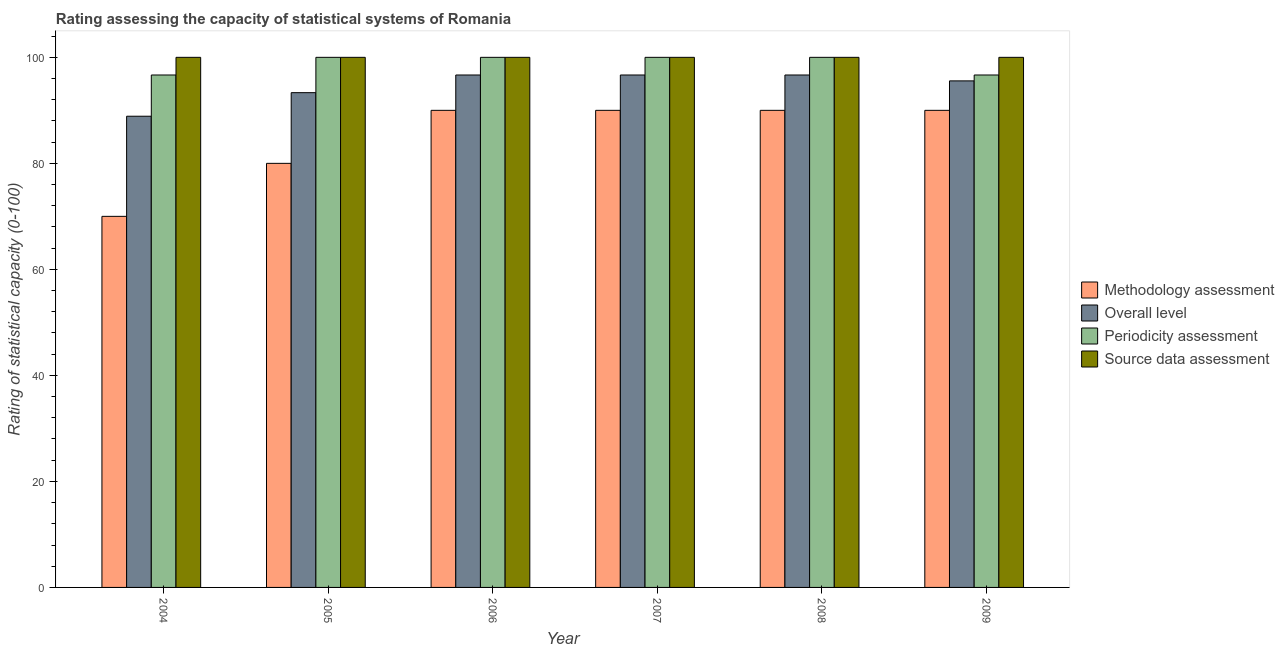How many different coloured bars are there?
Provide a succinct answer. 4. Are the number of bars per tick equal to the number of legend labels?
Give a very brief answer. Yes. How many bars are there on the 2nd tick from the left?
Keep it short and to the point. 4. What is the methodology assessment rating in 2009?
Your answer should be very brief. 90. Across all years, what is the maximum overall level rating?
Keep it short and to the point. 96.67. Across all years, what is the minimum periodicity assessment rating?
Your answer should be compact. 96.67. In which year was the source data assessment rating maximum?
Provide a succinct answer. 2004. What is the total overall level rating in the graph?
Your answer should be compact. 567.78. What is the difference between the source data assessment rating in 2005 and that in 2008?
Provide a succinct answer. 0. What is the difference between the source data assessment rating in 2004 and the overall level rating in 2006?
Keep it short and to the point. 0. What is the average periodicity assessment rating per year?
Your response must be concise. 98.89. In how many years, is the periodicity assessment rating greater than 16?
Keep it short and to the point. 6. What is the ratio of the overall level rating in 2004 to that in 2007?
Make the answer very short. 0.92. Is the periodicity assessment rating in 2006 less than that in 2007?
Provide a succinct answer. No. Is the difference between the methodology assessment rating in 2005 and 2008 greater than the difference between the periodicity assessment rating in 2005 and 2008?
Give a very brief answer. No. What is the difference between the highest and the second highest methodology assessment rating?
Offer a terse response. 0. What is the difference between the highest and the lowest periodicity assessment rating?
Your answer should be very brief. 3.33. In how many years, is the methodology assessment rating greater than the average methodology assessment rating taken over all years?
Give a very brief answer. 4. Is it the case that in every year, the sum of the methodology assessment rating and source data assessment rating is greater than the sum of overall level rating and periodicity assessment rating?
Offer a terse response. No. What does the 4th bar from the left in 2006 represents?
Give a very brief answer. Source data assessment. What does the 4th bar from the right in 2004 represents?
Ensure brevity in your answer.  Methodology assessment. Are all the bars in the graph horizontal?
Your response must be concise. No. Are the values on the major ticks of Y-axis written in scientific E-notation?
Keep it short and to the point. No. Does the graph contain any zero values?
Your answer should be compact. No. Does the graph contain grids?
Offer a terse response. No. Where does the legend appear in the graph?
Your answer should be compact. Center right. How are the legend labels stacked?
Make the answer very short. Vertical. What is the title of the graph?
Ensure brevity in your answer.  Rating assessing the capacity of statistical systems of Romania. Does "Quality of logistic services" appear as one of the legend labels in the graph?
Your answer should be compact. No. What is the label or title of the X-axis?
Offer a very short reply. Year. What is the label or title of the Y-axis?
Give a very brief answer. Rating of statistical capacity (0-100). What is the Rating of statistical capacity (0-100) in Overall level in 2004?
Provide a succinct answer. 88.89. What is the Rating of statistical capacity (0-100) in Periodicity assessment in 2004?
Your answer should be compact. 96.67. What is the Rating of statistical capacity (0-100) in Source data assessment in 2004?
Your response must be concise. 100. What is the Rating of statistical capacity (0-100) of Overall level in 2005?
Ensure brevity in your answer.  93.33. What is the Rating of statistical capacity (0-100) of Periodicity assessment in 2005?
Provide a short and direct response. 100. What is the Rating of statistical capacity (0-100) of Source data assessment in 2005?
Give a very brief answer. 100. What is the Rating of statistical capacity (0-100) in Overall level in 2006?
Make the answer very short. 96.67. What is the Rating of statistical capacity (0-100) of Periodicity assessment in 2006?
Offer a very short reply. 100. What is the Rating of statistical capacity (0-100) in Overall level in 2007?
Your response must be concise. 96.67. What is the Rating of statistical capacity (0-100) of Periodicity assessment in 2007?
Your answer should be very brief. 100. What is the Rating of statistical capacity (0-100) in Source data assessment in 2007?
Provide a succinct answer. 100. What is the Rating of statistical capacity (0-100) in Overall level in 2008?
Make the answer very short. 96.67. What is the Rating of statistical capacity (0-100) of Methodology assessment in 2009?
Give a very brief answer. 90. What is the Rating of statistical capacity (0-100) in Overall level in 2009?
Keep it short and to the point. 95.56. What is the Rating of statistical capacity (0-100) in Periodicity assessment in 2009?
Your answer should be very brief. 96.67. Across all years, what is the maximum Rating of statistical capacity (0-100) in Methodology assessment?
Your answer should be very brief. 90. Across all years, what is the maximum Rating of statistical capacity (0-100) of Overall level?
Offer a terse response. 96.67. Across all years, what is the minimum Rating of statistical capacity (0-100) in Overall level?
Offer a terse response. 88.89. Across all years, what is the minimum Rating of statistical capacity (0-100) in Periodicity assessment?
Your answer should be very brief. 96.67. Across all years, what is the minimum Rating of statistical capacity (0-100) in Source data assessment?
Ensure brevity in your answer.  100. What is the total Rating of statistical capacity (0-100) of Methodology assessment in the graph?
Offer a terse response. 510. What is the total Rating of statistical capacity (0-100) of Overall level in the graph?
Give a very brief answer. 567.78. What is the total Rating of statistical capacity (0-100) of Periodicity assessment in the graph?
Provide a succinct answer. 593.33. What is the total Rating of statistical capacity (0-100) of Source data assessment in the graph?
Provide a succinct answer. 600. What is the difference between the Rating of statistical capacity (0-100) in Overall level in 2004 and that in 2005?
Make the answer very short. -4.44. What is the difference between the Rating of statistical capacity (0-100) in Source data assessment in 2004 and that in 2005?
Keep it short and to the point. 0. What is the difference between the Rating of statistical capacity (0-100) of Methodology assessment in 2004 and that in 2006?
Offer a very short reply. -20. What is the difference between the Rating of statistical capacity (0-100) of Overall level in 2004 and that in 2006?
Your response must be concise. -7.78. What is the difference between the Rating of statistical capacity (0-100) of Source data assessment in 2004 and that in 2006?
Provide a succinct answer. 0. What is the difference between the Rating of statistical capacity (0-100) in Methodology assessment in 2004 and that in 2007?
Offer a terse response. -20. What is the difference between the Rating of statistical capacity (0-100) of Overall level in 2004 and that in 2007?
Make the answer very short. -7.78. What is the difference between the Rating of statistical capacity (0-100) in Source data assessment in 2004 and that in 2007?
Provide a short and direct response. 0. What is the difference between the Rating of statistical capacity (0-100) of Methodology assessment in 2004 and that in 2008?
Ensure brevity in your answer.  -20. What is the difference between the Rating of statistical capacity (0-100) in Overall level in 2004 and that in 2008?
Provide a succinct answer. -7.78. What is the difference between the Rating of statistical capacity (0-100) of Periodicity assessment in 2004 and that in 2008?
Give a very brief answer. -3.33. What is the difference between the Rating of statistical capacity (0-100) of Overall level in 2004 and that in 2009?
Give a very brief answer. -6.67. What is the difference between the Rating of statistical capacity (0-100) of Periodicity assessment in 2004 and that in 2009?
Provide a succinct answer. 0. What is the difference between the Rating of statistical capacity (0-100) of Overall level in 2005 and that in 2006?
Ensure brevity in your answer.  -3.33. What is the difference between the Rating of statistical capacity (0-100) of Methodology assessment in 2005 and that in 2007?
Your answer should be compact. -10. What is the difference between the Rating of statistical capacity (0-100) of Source data assessment in 2005 and that in 2007?
Your answer should be compact. 0. What is the difference between the Rating of statistical capacity (0-100) in Methodology assessment in 2005 and that in 2008?
Ensure brevity in your answer.  -10. What is the difference between the Rating of statistical capacity (0-100) of Overall level in 2005 and that in 2008?
Your response must be concise. -3.33. What is the difference between the Rating of statistical capacity (0-100) of Periodicity assessment in 2005 and that in 2008?
Offer a very short reply. 0. What is the difference between the Rating of statistical capacity (0-100) in Overall level in 2005 and that in 2009?
Provide a short and direct response. -2.22. What is the difference between the Rating of statistical capacity (0-100) of Periodicity assessment in 2005 and that in 2009?
Provide a succinct answer. 3.33. What is the difference between the Rating of statistical capacity (0-100) of Source data assessment in 2005 and that in 2009?
Give a very brief answer. 0. What is the difference between the Rating of statistical capacity (0-100) in Periodicity assessment in 2006 and that in 2007?
Make the answer very short. 0. What is the difference between the Rating of statistical capacity (0-100) in Source data assessment in 2006 and that in 2007?
Offer a terse response. 0. What is the difference between the Rating of statistical capacity (0-100) in Overall level in 2006 and that in 2008?
Your response must be concise. 0. What is the difference between the Rating of statistical capacity (0-100) of Methodology assessment in 2007 and that in 2008?
Make the answer very short. 0. What is the difference between the Rating of statistical capacity (0-100) of Overall level in 2007 and that in 2009?
Provide a succinct answer. 1.11. What is the difference between the Rating of statistical capacity (0-100) in Periodicity assessment in 2007 and that in 2009?
Keep it short and to the point. 3.33. What is the difference between the Rating of statistical capacity (0-100) of Source data assessment in 2007 and that in 2009?
Offer a very short reply. 0. What is the difference between the Rating of statistical capacity (0-100) of Periodicity assessment in 2008 and that in 2009?
Ensure brevity in your answer.  3.33. What is the difference between the Rating of statistical capacity (0-100) of Methodology assessment in 2004 and the Rating of statistical capacity (0-100) of Overall level in 2005?
Your response must be concise. -23.33. What is the difference between the Rating of statistical capacity (0-100) in Methodology assessment in 2004 and the Rating of statistical capacity (0-100) in Periodicity assessment in 2005?
Your answer should be very brief. -30. What is the difference between the Rating of statistical capacity (0-100) of Overall level in 2004 and the Rating of statistical capacity (0-100) of Periodicity assessment in 2005?
Your answer should be compact. -11.11. What is the difference between the Rating of statistical capacity (0-100) of Overall level in 2004 and the Rating of statistical capacity (0-100) of Source data assessment in 2005?
Make the answer very short. -11.11. What is the difference between the Rating of statistical capacity (0-100) of Periodicity assessment in 2004 and the Rating of statistical capacity (0-100) of Source data assessment in 2005?
Your answer should be compact. -3.33. What is the difference between the Rating of statistical capacity (0-100) of Methodology assessment in 2004 and the Rating of statistical capacity (0-100) of Overall level in 2006?
Your answer should be very brief. -26.67. What is the difference between the Rating of statistical capacity (0-100) in Methodology assessment in 2004 and the Rating of statistical capacity (0-100) in Source data assessment in 2006?
Your response must be concise. -30. What is the difference between the Rating of statistical capacity (0-100) of Overall level in 2004 and the Rating of statistical capacity (0-100) of Periodicity assessment in 2006?
Keep it short and to the point. -11.11. What is the difference between the Rating of statistical capacity (0-100) in Overall level in 2004 and the Rating of statistical capacity (0-100) in Source data assessment in 2006?
Give a very brief answer. -11.11. What is the difference between the Rating of statistical capacity (0-100) of Methodology assessment in 2004 and the Rating of statistical capacity (0-100) of Overall level in 2007?
Offer a very short reply. -26.67. What is the difference between the Rating of statistical capacity (0-100) in Methodology assessment in 2004 and the Rating of statistical capacity (0-100) in Source data assessment in 2007?
Give a very brief answer. -30. What is the difference between the Rating of statistical capacity (0-100) of Overall level in 2004 and the Rating of statistical capacity (0-100) of Periodicity assessment in 2007?
Provide a succinct answer. -11.11. What is the difference between the Rating of statistical capacity (0-100) in Overall level in 2004 and the Rating of statistical capacity (0-100) in Source data assessment in 2007?
Ensure brevity in your answer.  -11.11. What is the difference between the Rating of statistical capacity (0-100) of Periodicity assessment in 2004 and the Rating of statistical capacity (0-100) of Source data assessment in 2007?
Your answer should be compact. -3.33. What is the difference between the Rating of statistical capacity (0-100) in Methodology assessment in 2004 and the Rating of statistical capacity (0-100) in Overall level in 2008?
Provide a short and direct response. -26.67. What is the difference between the Rating of statistical capacity (0-100) in Methodology assessment in 2004 and the Rating of statistical capacity (0-100) in Source data assessment in 2008?
Offer a terse response. -30. What is the difference between the Rating of statistical capacity (0-100) of Overall level in 2004 and the Rating of statistical capacity (0-100) of Periodicity assessment in 2008?
Your answer should be compact. -11.11. What is the difference between the Rating of statistical capacity (0-100) of Overall level in 2004 and the Rating of statistical capacity (0-100) of Source data assessment in 2008?
Your answer should be very brief. -11.11. What is the difference between the Rating of statistical capacity (0-100) of Periodicity assessment in 2004 and the Rating of statistical capacity (0-100) of Source data assessment in 2008?
Offer a very short reply. -3.33. What is the difference between the Rating of statistical capacity (0-100) in Methodology assessment in 2004 and the Rating of statistical capacity (0-100) in Overall level in 2009?
Your response must be concise. -25.56. What is the difference between the Rating of statistical capacity (0-100) of Methodology assessment in 2004 and the Rating of statistical capacity (0-100) of Periodicity assessment in 2009?
Your answer should be compact. -26.67. What is the difference between the Rating of statistical capacity (0-100) in Methodology assessment in 2004 and the Rating of statistical capacity (0-100) in Source data assessment in 2009?
Make the answer very short. -30. What is the difference between the Rating of statistical capacity (0-100) in Overall level in 2004 and the Rating of statistical capacity (0-100) in Periodicity assessment in 2009?
Provide a short and direct response. -7.78. What is the difference between the Rating of statistical capacity (0-100) of Overall level in 2004 and the Rating of statistical capacity (0-100) of Source data assessment in 2009?
Keep it short and to the point. -11.11. What is the difference between the Rating of statistical capacity (0-100) of Methodology assessment in 2005 and the Rating of statistical capacity (0-100) of Overall level in 2006?
Offer a terse response. -16.67. What is the difference between the Rating of statistical capacity (0-100) of Methodology assessment in 2005 and the Rating of statistical capacity (0-100) of Source data assessment in 2006?
Keep it short and to the point. -20. What is the difference between the Rating of statistical capacity (0-100) in Overall level in 2005 and the Rating of statistical capacity (0-100) in Periodicity assessment in 2006?
Provide a short and direct response. -6.67. What is the difference between the Rating of statistical capacity (0-100) in Overall level in 2005 and the Rating of statistical capacity (0-100) in Source data assessment in 2006?
Provide a short and direct response. -6.67. What is the difference between the Rating of statistical capacity (0-100) in Periodicity assessment in 2005 and the Rating of statistical capacity (0-100) in Source data assessment in 2006?
Provide a succinct answer. 0. What is the difference between the Rating of statistical capacity (0-100) of Methodology assessment in 2005 and the Rating of statistical capacity (0-100) of Overall level in 2007?
Make the answer very short. -16.67. What is the difference between the Rating of statistical capacity (0-100) in Methodology assessment in 2005 and the Rating of statistical capacity (0-100) in Source data assessment in 2007?
Keep it short and to the point. -20. What is the difference between the Rating of statistical capacity (0-100) in Overall level in 2005 and the Rating of statistical capacity (0-100) in Periodicity assessment in 2007?
Your response must be concise. -6.67. What is the difference between the Rating of statistical capacity (0-100) in Overall level in 2005 and the Rating of statistical capacity (0-100) in Source data assessment in 2007?
Offer a terse response. -6.67. What is the difference between the Rating of statistical capacity (0-100) in Methodology assessment in 2005 and the Rating of statistical capacity (0-100) in Overall level in 2008?
Your response must be concise. -16.67. What is the difference between the Rating of statistical capacity (0-100) in Methodology assessment in 2005 and the Rating of statistical capacity (0-100) in Source data assessment in 2008?
Your answer should be compact. -20. What is the difference between the Rating of statistical capacity (0-100) in Overall level in 2005 and the Rating of statistical capacity (0-100) in Periodicity assessment in 2008?
Ensure brevity in your answer.  -6.67. What is the difference between the Rating of statistical capacity (0-100) of Overall level in 2005 and the Rating of statistical capacity (0-100) of Source data assessment in 2008?
Offer a very short reply. -6.67. What is the difference between the Rating of statistical capacity (0-100) of Methodology assessment in 2005 and the Rating of statistical capacity (0-100) of Overall level in 2009?
Provide a short and direct response. -15.56. What is the difference between the Rating of statistical capacity (0-100) of Methodology assessment in 2005 and the Rating of statistical capacity (0-100) of Periodicity assessment in 2009?
Offer a very short reply. -16.67. What is the difference between the Rating of statistical capacity (0-100) of Methodology assessment in 2005 and the Rating of statistical capacity (0-100) of Source data assessment in 2009?
Give a very brief answer. -20. What is the difference between the Rating of statistical capacity (0-100) of Overall level in 2005 and the Rating of statistical capacity (0-100) of Periodicity assessment in 2009?
Your answer should be very brief. -3.33. What is the difference between the Rating of statistical capacity (0-100) of Overall level in 2005 and the Rating of statistical capacity (0-100) of Source data assessment in 2009?
Your response must be concise. -6.67. What is the difference between the Rating of statistical capacity (0-100) of Periodicity assessment in 2005 and the Rating of statistical capacity (0-100) of Source data assessment in 2009?
Offer a very short reply. 0. What is the difference between the Rating of statistical capacity (0-100) in Methodology assessment in 2006 and the Rating of statistical capacity (0-100) in Overall level in 2007?
Your response must be concise. -6.67. What is the difference between the Rating of statistical capacity (0-100) in Methodology assessment in 2006 and the Rating of statistical capacity (0-100) in Periodicity assessment in 2007?
Your answer should be compact. -10. What is the difference between the Rating of statistical capacity (0-100) of Periodicity assessment in 2006 and the Rating of statistical capacity (0-100) of Source data assessment in 2007?
Keep it short and to the point. 0. What is the difference between the Rating of statistical capacity (0-100) in Methodology assessment in 2006 and the Rating of statistical capacity (0-100) in Overall level in 2008?
Your answer should be very brief. -6.67. What is the difference between the Rating of statistical capacity (0-100) in Methodology assessment in 2006 and the Rating of statistical capacity (0-100) in Periodicity assessment in 2008?
Make the answer very short. -10. What is the difference between the Rating of statistical capacity (0-100) in Overall level in 2006 and the Rating of statistical capacity (0-100) in Periodicity assessment in 2008?
Ensure brevity in your answer.  -3.33. What is the difference between the Rating of statistical capacity (0-100) of Overall level in 2006 and the Rating of statistical capacity (0-100) of Source data assessment in 2008?
Provide a succinct answer. -3.33. What is the difference between the Rating of statistical capacity (0-100) of Methodology assessment in 2006 and the Rating of statistical capacity (0-100) of Overall level in 2009?
Make the answer very short. -5.56. What is the difference between the Rating of statistical capacity (0-100) of Methodology assessment in 2006 and the Rating of statistical capacity (0-100) of Periodicity assessment in 2009?
Offer a very short reply. -6.67. What is the difference between the Rating of statistical capacity (0-100) of Overall level in 2006 and the Rating of statistical capacity (0-100) of Source data assessment in 2009?
Offer a terse response. -3.33. What is the difference between the Rating of statistical capacity (0-100) of Methodology assessment in 2007 and the Rating of statistical capacity (0-100) of Overall level in 2008?
Keep it short and to the point. -6.67. What is the difference between the Rating of statistical capacity (0-100) in Methodology assessment in 2007 and the Rating of statistical capacity (0-100) in Periodicity assessment in 2008?
Your response must be concise. -10. What is the difference between the Rating of statistical capacity (0-100) of Methodology assessment in 2007 and the Rating of statistical capacity (0-100) of Overall level in 2009?
Keep it short and to the point. -5.56. What is the difference between the Rating of statistical capacity (0-100) in Methodology assessment in 2007 and the Rating of statistical capacity (0-100) in Periodicity assessment in 2009?
Offer a very short reply. -6.67. What is the difference between the Rating of statistical capacity (0-100) in Overall level in 2007 and the Rating of statistical capacity (0-100) in Periodicity assessment in 2009?
Your response must be concise. -0. What is the difference between the Rating of statistical capacity (0-100) of Periodicity assessment in 2007 and the Rating of statistical capacity (0-100) of Source data assessment in 2009?
Make the answer very short. 0. What is the difference between the Rating of statistical capacity (0-100) in Methodology assessment in 2008 and the Rating of statistical capacity (0-100) in Overall level in 2009?
Your response must be concise. -5.56. What is the difference between the Rating of statistical capacity (0-100) of Methodology assessment in 2008 and the Rating of statistical capacity (0-100) of Periodicity assessment in 2009?
Give a very brief answer. -6.67. What is the difference between the Rating of statistical capacity (0-100) of Methodology assessment in 2008 and the Rating of statistical capacity (0-100) of Source data assessment in 2009?
Your answer should be very brief. -10. What is the difference between the Rating of statistical capacity (0-100) in Overall level in 2008 and the Rating of statistical capacity (0-100) in Periodicity assessment in 2009?
Your response must be concise. -0. What is the difference between the Rating of statistical capacity (0-100) of Periodicity assessment in 2008 and the Rating of statistical capacity (0-100) of Source data assessment in 2009?
Give a very brief answer. 0. What is the average Rating of statistical capacity (0-100) in Overall level per year?
Give a very brief answer. 94.63. What is the average Rating of statistical capacity (0-100) in Periodicity assessment per year?
Provide a short and direct response. 98.89. What is the average Rating of statistical capacity (0-100) in Source data assessment per year?
Ensure brevity in your answer.  100. In the year 2004, what is the difference between the Rating of statistical capacity (0-100) of Methodology assessment and Rating of statistical capacity (0-100) of Overall level?
Give a very brief answer. -18.89. In the year 2004, what is the difference between the Rating of statistical capacity (0-100) of Methodology assessment and Rating of statistical capacity (0-100) of Periodicity assessment?
Your answer should be compact. -26.67. In the year 2004, what is the difference between the Rating of statistical capacity (0-100) of Overall level and Rating of statistical capacity (0-100) of Periodicity assessment?
Keep it short and to the point. -7.78. In the year 2004, what is the difference between the Rating of statistical capacity (0-100) in Overall level and Rating of statistical capacity (0-100) in Source data assessment?
Your answer should be very brief. -11.11. In the year 2004, what is the difference between the Rating of statistical capacity (0-100) in Periodicity assessment and Rating of statistical capacity (0-100) in Source data assessment?
Offer a very short reply. -3.33. In the year 2005, what is the difference between the Rating of statistical capacity (0-100) of Methodology assessment and Rating of statistical capacity (0-100) of Overall level?
Your response must be concise. -13.33. In the year 2005, what is the difference between the Rating of statistical capacity (0-100) of Overall level and Rating of statistical capacity (0-100) of Periodicity assessment?
Provide a succinct answer. -6.67. In the year 2005, what is the difference between the Rating of statistical capacity (0-100) in Overall level and Rating of statistical capacity (0-100) in Source data assessment?
Provide a succinct answer. -6.67. In the year 2005, what is the difference between the Rating of statistical capacity (0-100) in Periodicity assessment and Rating of statistical capacity (0-100) in Source data assessment?
Offer a very short reply. 0. In the year 2006, what is the difference between the Rating of statistical capacity (0-100) in Methodology assessment and Rating of statistical capacity (0-100) in Overall level?
Ensure brevity in your answer.  -6.67. In the year 2006, what is the difference between the Rating of statistical capacity (0-100) in Overall level and Rating of statistical capacity (0-100) in Periodicity assessment?
Your response must be concise. -3.33. In the year 2007, what is the difference between the Rating of statistical capacity (0-100) of Methodology assessment and Rating of statistical capacity (0-100) of Overall level?
Offer a very short reply. -6.67. In the year 2007, what is the difference between the Rating of statistical capacity (0-100) of Methodology assessment and Rating of statistical capacity (0-100) of Source data assessment?
Offer a terse response. -10. In the year 2007, what is the difference between the Rating of statistical capacity (0-100) in Overall level and Rating of statistical capacity (0-100) in Source data assessment?
Your response must be concise. -3.33. In the year 2008, what is the difference between the Rating of statistical capacity (0-100) of Methodology assessment and Rating of statistical capacity (0-100) of Overall level?
Offer a terse response. -6.67. In the year 2008, what is the difference between the Rating of statistical capacity (0-100) of Methodology assessment and Rating of statistical capacity (0-100) of Source data assessment?
Make the answer very short. -10. In the year 2008, what is the difference between the Rating of statistical capacity (0-100) of Overall level and Rating of statistical capacity (0-100) of Periodicity assessment?
Ensure brevity in your answer.  -3.33. In the year 2008, what is the difference between the Rating of statistical capacity (0-100) in Overall level and Rating of statistical capacity (0-100) in Source data assessment?
Offer a terse response. -3.33. In the year 2009, what is the difference between the Rating of statistical capacity (0-100) of Methodology assessment and Rating of statistical capacity (0-100) of Overall level?
Your response must be concise. -5.56. In the year 2009, what is the difference between the Rating of statistical capacity (0-100) in Methodology assessment and Rating of statistical capacity (0-100) in Periodicity assessment?
Ensure brevity in your answer.  -6.67. In the year 2009, what is the difference between the Rating of statistical capacity (0-100) of Methodology assessment and Rating of statistical capacity (0-100) of Source data assessment?
Ensure brevity in your answer.  -10. In the year 2009, what is the difference between the Rating of statistical capacity (0-100) in Overall level and Rating of statistical capacity (0-100) in Periodicity assessment?
Offer a terse response. -1.11. In the year 2009, what is the difference between the Rating of statistical capacity (0-100) in Overall level and Rating of statistical capacity (0-100) in Source data assessment?
Provide a succinct answer. -4.44. In the year 2009, what is the difference between the Rating of statistical capacity (0-100) of Periodicity assessment and Rating of statistical capacity (0-100) of Source data assessment?
Your answer should be compact. -3.33. What is the ratio of the Rating of statistical capacity (0-100) in Methodology assessment in 2004 to that in 2005?
Offer a terse response. 0.88. What is the ratio of the Rating of statistical capacity (0-100) in Overall level in 2004 to that in 2005?
Your answer should be compact. 0.95. What is the ratio of the Rating of statistical capacity (0-100) in Periodicity assessment in 2004 to that in 2005?
Ensure brevity in your answer.  0.97. What is the ratio of the Rating of statistical capacity (0-100) of Methodology assessment in 2004 to that in 2006?
Your answer should be very brief. 0.78. What is the ratio of the Rating of statistical capacity (0-100) of Overall level in 2004 to that in 2006?
Provide a short and direct response. 0.92. What is the ratio of the Rating of statistical capacity (0-100) of Periodicity assessment in 2004 to that in 2006?
Your answer should be compact. 0.97. What is the ratio of the Rating of statistical capacity (0-100) of Source data assessment in 2004 to that in 2006?
Your answer should be very brief. 1. What is the ratio of the Rating of statistical capacity (0-100) of Methodology assessment in 2004 to that in 2007?
Give a very brief answer. 0.78. What is the ratio of the Rating of statistical capacity (0-100) in Overall level in 2004 to that in 2007?
Ensure brevity in your answer.  0.92. What is the ratio of the Rating of statistical capacity (0-100) in Periodicity assessment in 2004 to that in 2007?
Offer a very short reply. 0.97. What is the ratio of the Rating of statistical capacity (0-100) in Overall level in 2004 to that in 2008?
Offer a terse response. 0.92. What is the ratio of the Rating of statistical capacity (0-100) of Periodicity assessment in 2004 to that in 2008?
Make the answer very short. 0.97. What is the ratio of the Rating of statistical capacity (0-100) in Overall level in 2004 to that in 2009?
Offer a very short reply. 0.93. What is the ratio of the Rating of statistical capacity (0-100) of Overall level in 2005 to that in 2006?
Give a very brief answer. 0.97. What is the ratio of the Rating of statistical capacity (0-100) of Source data assessment in 2005 to that in 2006?
Give a very brief answer. 1. What is the ratio of the Rating of statistical capacity (0-100) in Methodology assessment in 2005 to that in 2007?
Your response must be concise. 0.89. What is the ratio of the Rating of statistical capacity (0-100) of Overall level in 2005 to that in 2007?
Your response must be concise. 0.97. What is the ratio of the Rating of statistical capacity (0-100) in Overall level in 2005 to that in 2008?
Keep it short and to the point. 0.97. What is the ratio of the Rating of statistical capacity (0-100) in Source data assessment in 2005 to that in 2008?
Offer a terse response. 1. What is the ratio of the Rating of statistical capacity (0-100) of Overall level in 2005 to that in 2009?
Provide a short and direct response. 0.98. What is the ratio of the Rating of statistical capacity (0-100) in Periodicity assessment in 2005 to that in 2009?
Offer a terse response. 1.03. What is the ratio of the Rating of statistical capacity (0-100) of Source data assessment in 2005 to that in 2009?
Ensure brevity in your answer.  1. What is the ratio of the Rating of statistical capacity (0-100) in Overall level in 2006 to that in 2007?
Provide a succinct answer. 1. What is the ratio of the Rating of statistical capacity (0-100) of Periodicity assessment in 2006 to that in 2007?
Your answer should be compact. 1. What is the ratio of the Rating of statistical capacity (0-100) in Methodology assessment in 2006 to that in 2008?
Your answer should be compact. 1. What is the ratio of the Rating of statistical capacity (0-100) of Source data assessment in 2006 to that in 2008?
Keep it short and to the point. 1. What is the ratio of the Rating of statistical capacity (0-100) of Methodology assessment in 2006 to that in 2009?
Your answer should be very brief. 1. What is the ratio of the Rating of statistical capacity (0-100) of Overall level in 2006 to that in 2009?
Keep it short and to the point. 1.01. What is the ratio of the Rating of statistical capacity (0-100) in Periodicity assessment in 2006 to that in 2009?
Give a very brief answer. 1.03. What is the ratio of the Rating of statistical capacity (0-100) in Source data assessment in 2006 to that in 2009?
Ensure brevity in your answer.  1. What is the ratio of the Rating of statistical capacity (0-100) in Overall level in 2007 to that in 2008?
Offer a very short reply. 1. What is the ratio of the Rating of statistical capacity (0-100) of Source data assessment in 2007 to that in 2008?
Your answer should be compact. 1. What is the ratio of the Rating of statistical capacity (0-100) in Methodology assessment in 2007 to that in 2009?
Offer a very short reply. 1. What is the ratio of the Rating of statistical capacity (0-100) in Overall level in 2007 to that in 2009?
Keep it short and to the point. 1.01. What is the ratio of the Rating of statistical capacity (0-100) of Periodicity assessment in 2007 to that in 2009?
Give a very brief answer. 1.03. What is the ratio of the Rating of statistical capacity (0-100) in Source data assessment in 2007 to that in 2009?
Offer a very short reply. 1. What is the ratio of the Rating of statistical capacity (0-100) in Overall level in 2008 to that in 2009?
Ensure brevity in your answer.  1.01. What is the ratio of the Rating of statistical capacity (0-100) of Periodicity assessment in 2008 to that in 2009?
Your answer should be very brief. 1.03. What is the difference between the highest and the second highest Rating of statistical capacity (0-100) of Methodology assessment?
Your response must be concise. 0. What is the difference between the highest and the second highest Rating of statistical capacity (0-100) of Overall level?
Provide a succinct answer. 0. What is the difference between the highest and the lowest Rating of statistical capacity (0-100) in Overall level?
Ensure brevity in your answer.  7.78. 